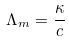<formula> <loc_0><loc_0><loc_500><loc_500>\Lambda _ { m } = \frac { \kappa } { c }</formula> 